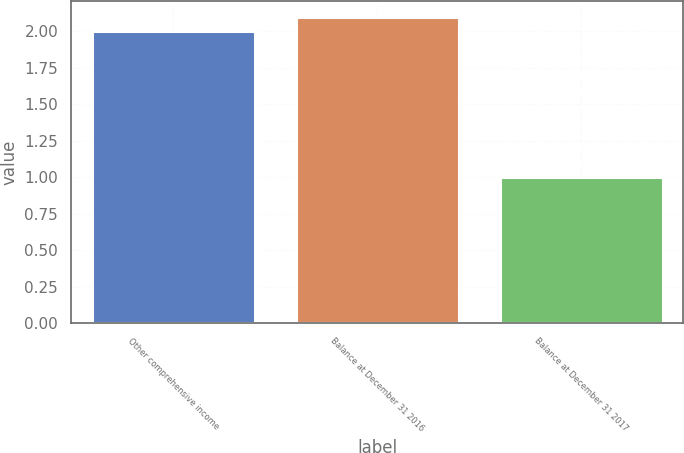<chart> <loc_0><loc_0><loc_500><loc_500><bar_chart><fcel>Other comprehensive income<fcel>Balance at December 31 2016<fcel>Balance at December 31 2017<nl><fcel>2<fcel>2.1<fcel>1<nl></chart> 